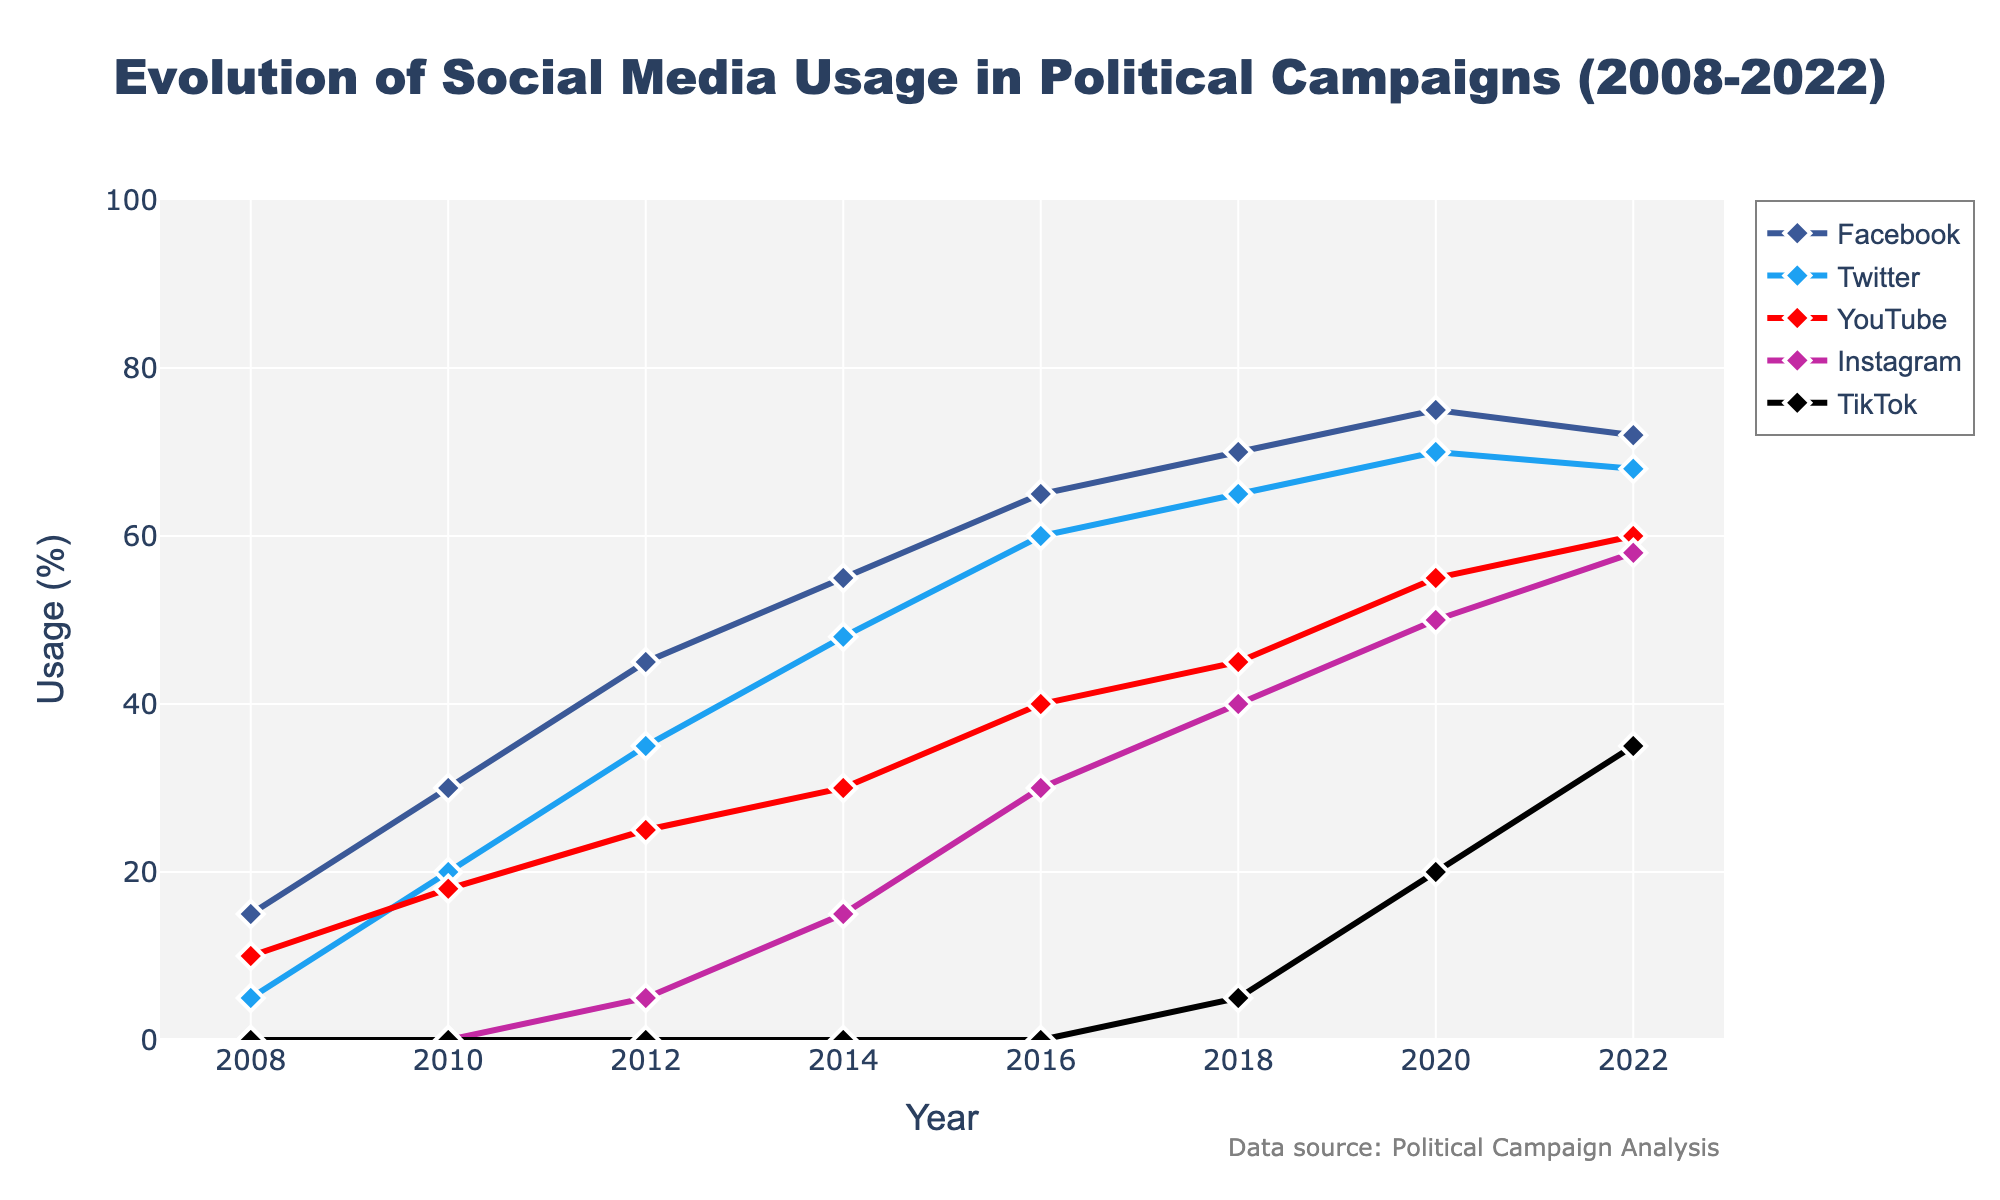What is the total change in Facebook usage from 2008 to 2022? Subtract the 2008 value from the 2022 value to find the total change: 72 (2022) - 15 (2008) = 57
Answer: 57 Which platform showed the most consistent growth over the years? By observing the lines on the chart, Twitter shows a steady, consistent increase in usage without any significant dips or plateaus.
Answer: Twitter In which year did TikTok usage first appear, and what was its percentage? The line for TikTok appears first in 2018 with a usage percentage of 5%.
Answer: 2018, 5% Did Instagram surpass YouTube in usage at any point, and if so, when? By comparing the lines, Instagram surpassed YouTube in 2020.
Answer: 2020 By how much did YouTube usage grow between 2008 and 2014? Subtract the 2008 value from the 2014 value for YouTube: 30 (2014) - 10 (2008) = 20
Answer: 20 How does the 2022 usage of Twitter compare to Facebook? The 2022 usage of Twitter is 68%, while Facebook is 72%. Twitter is 4 percentage points less than Facebook in 2022.
Answer: 4 percentage points less What is the average usage of Instagram from all years provided? Sum all the percentages for Instagram and then divide by the number of years: (0 + 0 + 5 + 15 + 30 + 40 + 50 + 58) / 8 = 198 / 8 = 24.75
Answer: 24.75 Which platform had the highest percentage increase between any two consecutive years, and during which period? TikTok increased from 5% in 2018 to 20% in 2020, a 15 percentage point increase, which is the highest among any platform between consecutive years.
Answer: TikTok, 2018-2020 In 2016, how much greater was the Facebook usage compared to Instagram usage? The usage for Facebook in 2016 was 65%, and for Instagram, it was 30%. The difference is 65 - 30 = 35 percentage points.
Answer: 35 